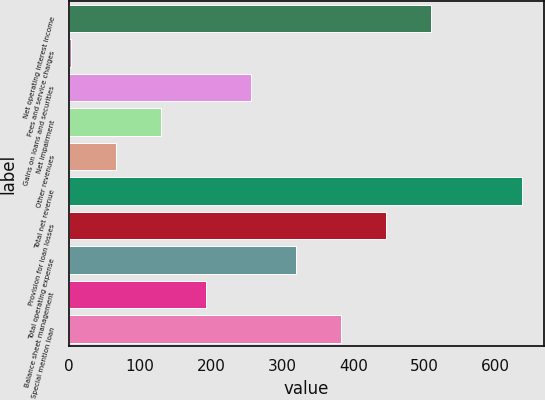<chart> <loc_0><loc_0><loc_500><loc_500><bar_chart><fcel>Net operating interest income<fcel>Fees and service charges<fcel>Gains on loans and securities<fcel>Net impairment<fcel>Other revenues<fcel>Total net revenue<fcel>Provision for loan losses<fcel>Total operating expense<fcel>Balance sheet management<fcel>Special mention loan<nl><fcel>510<fcel>2.8<fcel>256.4<fcel>129.6<fcel>66.2<fcel>636.8<fcel>446.6<fcel>319.8<fcel>193<fcel>383.2<nl></chart> 